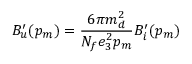Convert formula to latex. <formula><loc_0><loc_0><loc_500><loc_500>B _ { u } ^ { \prime } ( p _ { m } ) = \frac { 6 \pi m _ { d } ^ { 2 } } { N _ { f } e _ { 3 } ^ { 2 } p _ { m } } B _ { i } ^ { \prime } ( p _ { m } )</formula> 